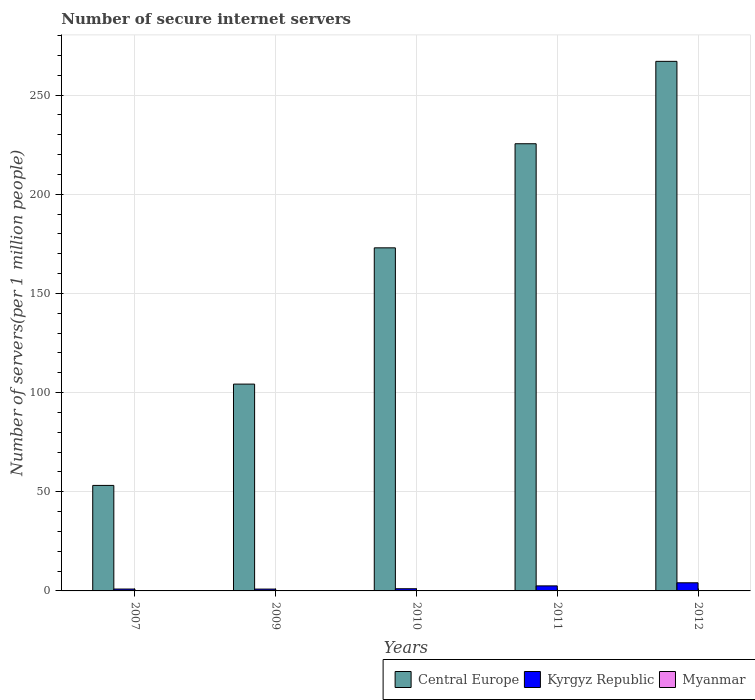Are the number of bars on each tick of the X-axis equal?
Provide a succinct answer. Yes. How many bars are there on the 4th tick from the left?
Offer a terse response. 3. What is the label of the 1st group of bars from the left?
Make the answer very short. 2007. What is the number of secure internet servers in Myanmar in 2009?
Ensure brevity in your answer.  0.02. Across all years, what is the maximum number of secure internet servers in Kyrgyz Republic?
Offer a terse response. 4.1. Across all years, what is the minimum number of secure internet servers in Myanmar?
Your response must be concise. 0.02. In which year was the number of secure internet servers in Kyrgyz Republic maximum?
Give a very brief answer. 2012. In which year was the number of secure internet servers in Myanmar minimum?
Offer a very short reply. 2009. What is the total number of secure internet servers in Kyrgyz Republic in the graph?
Your answer should be very brief. 9.62. What is the difference between the number of secure internet servers in Myanmar in 2007 and that in 2009?
Keep it short and to the point. 0. What is the difference between the number of secure internet servers in Kyrgyz Republic in 2011 and the number of secure internet servers in Central Europe in 2012?
Your answer should be compact. -264.44. What is the average number of secure internet servers in Myanmar per year?
Your answer should be very brief. 0.05. In the year 2010, what is the difference between the number of secure internet servers in Central Europe and number of secure internet servers in Myanmar?
Provide a short and direct response. 172.91. What is the ratio of the number of secure internet servers in Kyrgyz Republic in 2007 to that in 2010?
Give a very brief answer. 0.86. Is the difference between the number of secure internet servers in Central Europe in 2007 and 2010 greater than the difference between the number of secure internet servers in Myanmar in 2007 and 2010?
Your response must be concise. No. What is the difference between the highest and the second highest number of secure internet servers in Kyrgyz Republic?
Provide a succinct answer. 1.56. What is the difference between the highest and the lowest number of secure internet servers in Myanmar?
Offer a terse response. 0.08. Is the sum of the number of secure internet servers in Central Europe in 2010 and 2011 greater than the maximum number of secure internet servers in Myanmar across all years?
Provide a succinct answer. Yes. What does the 1st bar from the left in 2009 represents?
Your answer should be very brief. Central Europe. What does the 3rd bar from the right in 2007 represents?
Offer a very short reply. Central Europe. How many bars are there?
Keep it short and to the point. 15. Are the values on the major ticks of Y-axis written in scientific E-notation?
Offer a very short reply. No. Does the graph contain grids?
Offer a very short reply. Yes. Where does the legend appear in the graph?
Give a very brief answer. Bottom right. How are the legend labels stacked?
Provide a short and direct response. Horizontal. What is the title of the graph?
Your answer should be compact. Number of secure internet servers. Does "High income" appear as one of the legend labels in the graph?
Provide a succinct answer. No. What is the label or title of the Y-axis?
Keep it short and to the point. Number of servers(per 1 million people). What is the Number of servers(per 1 million people) of Central Europe in 2007?
Give a very brief answer. 53.19. What is the Number of servers(per 1 million people) of Kyrgyz Republic in 2007?
Offer a very short reply. 0.95. What is the Number of servers(per 1 million people) in Myanmar in 2007?
Give a very brief answer. 0.02. What is the Number of servers(per 1 million people) in Central Europe in 2009?
Provide a succinct answer. 104.27. What is the Number of servers(per 1 million people) in Kyrgyz Republic in 2009?
Ensure brevity in your answer.  0.93. What is the Number of servers(per 1 million people) of Myanmar in 2009?
Keep it short and to the point. 0.02. What is the Number of servers(per 1 million people) in Central Europe in 2010?
Give a very brief answer. 172.97. What is the Number of servers(per 1 million people) in Kyrgyz Republic in 2010?
Give a very brief answer. 1.1. What is the Number of servers(per 1 million people) of Myanmar in 2010?
Keep it short and to the point. 0.06. What is the Number of servers(per 1 million people) of Central Europe in 2011?
Provide a short and direct response. 225.45. What is the Number of servers(per 1 million people) in Kyrgyz Republic in 2011?
Ensure brevity in your answer.  2.54. What is the Number of servers(per 1 million people) of Myanmar in 2011?
Provide a succinct answer. 0.08. What is the Number of servers(per 1 million people) of Central Europe in 2012?
Provide a short and direct response. 266.98. What is the Number of servers(per 1 million people) in Kyrgyz Republic in 2012?
Offer a terse response. 4.1. What is the Number of servers(per 1 million people) of Myanmar in 2012?
Ensure brevity in your answer.  0.1. Across all years, what is the maximum Number of servers(per 1 million people) in Central Europe?
Offer a very short reply. 266.98. Across all years, what is the maximum Number of servers(per 1 million people) of Kyrgyz Republic?
Ensure brevity in your answer.  4.1. Across all years, what is the maximum Number of servers(per 1 million people) of Myanmar?
Offer a very short reply. 0.1. Across all years, what is the minimum Number of servers(per 1 million people) in Central Europe?
Offer a terse response. 53.19. Across all years, what is the minimum Number of servers(per 1 million people) in Kyrgyz Republic?
Keep it short and to the point. 0.93. Across all years, what is the minimum Number of servers(per 1 million people) of Myanmar?
Offer a terse response. 0.02. What is the total Number of servers(per 1 million people) of Central Europe in the graph?
Offer a very short reply. 822.86. What is the total Number of servers(per 1 million people) in Kyrgyz Republic in the graph?
Your response must be concise. 9.62. What is the total Number of servers(per 1 million people) in Myanmar in the graph?
Your response must be concise. 0.27. What is the difference between the Number of servers(per 1 million people) of Central Europe in 2007 and that in 2009?
Your answer should be very brief. -51.07. What is the difference between the Number of servers(per 1 million people) of Kyrgyz Republic in 2007 and that in 2009?
Provide a succinct answer. 0.02. What is the difference between the Number of servers(per 1 million people) in Myanmar in 2007 and that in 2009?
Make the answer very short. 0. What is the difference between the Number of servers(per 1 million people) in Central Europe in 2007 and that in 2010?
Your response must be concise. -119.78. What is the difference between the Number of servers(per 1 million people) in Kyrgyz Republic in 2007 and that in 2010?
Provide a short and direct response. -0.15. What is the difference between the Number of servers(per 1 million people) in Myanmar in 2007 and that in 2010?
Ensure brevity in your answer.  -0.04. What is the difference between the Number of servers(per 1 million people) in Central Europe in 2007 and that in 2011?
Your response must be concise. -172.26. What is the difference between the Number of servers(per 1 million people) in Kyrgyz Republic in 2007 and that in 2011?
Provide a succinct answer. -1.59. What is the difference between the Number of servers(per 1 million people) in Myanmar in 2007 and that in 2011?
Keep it short and to the point. -0.06. What is the difference between the Number of servers(per 1 million people) of Central Europe in 2007 and that in 2012?
Your answer should be very brief. -213.79. What is the difference between the Number of servers(per 1 million people) in Kyrgyz Republic in 2007 and that in 2012?
Your response must be concise. -3.15. What is the difference between the Number of servers(per 1 million people) in Myanmar in 2007 and that in 2012?
Provide a succinct answer. -0.08. What is the difference between the Number of servers(per 1 million people) in Central Europe in 2009 and that in 2010?
Make the answer very short. -68.7. What is the difference between the Number of servers(per 1 million people) in Kyrgyz Republic in 2009 and that in 2010?
Ensure brevity in your answer.  -0.17. What is the difference between the Number of servers(per 1 million people) in Myanmar in 2009 and that in 2010?
Your answer should be compact. -0.04. What is the difference between the Number of servers(per 1 million people) in Central Europe in 2009 and that in 2011?
Offer a very short reply. -121.18. What is the difference between the Number of servers(per 1 million people) of Kyrgyz Republic in 2009 and that in 2011?
Provide a succinct answer. -1.61. What is the difference between the Number of servers(per 1 million people) of Myanmar in 2009 and that in 2011?
Keep it short and to the point. -0.06. What is the difference between the Number of servers(per 1 million people) in Central Europe in 2009 and that in 2012?
Ensure brevity in your answer.  -162.72. What is the difference between the Number of servers(per 1 million people) of Kyrgyz Republic in 2009 and that in 2012?
Your answer should be very brief. -3.17. What is the difference between the Number of servers(per 1 million people) of Myanmar in 2009 and that in 2012?
Offer a very short reply. -0.08. What is the difference between the Number of servers(per 1 million people) of Central Europe in 2010 and that in 2011?
Provide a short and direct response. -52.48. What is the difference between the Number of servers(per 1 million people) of Kyrgyz Republic in 2010 and that in 2011?
Offer a terse response. -1.44. What is the difference between the Number of servers(per 1 million people) of Myanmar in 2010 and that in 2011?
Make the answer very short. -0.02. What is the difference between the Number of servers(per 1 million people) in Central Europe in 2010 and that in 2012?
Ensure brevity in your answer.  -94.01. What is the difference between the Number of servers(per 1 million people) in Kyrgyz Republic in 2010 and that in 2012?
Offer a terse response. -3. What is the difference between the Number of servers(per 1 million people) of Myanmar in 2010 and that in 2012?
Your answer should be very brief. -0.04. What is the difference between the Number of servers(per 1 million people) of Central Europe in 2011 and that in 2012?
Provide a short and direct response. -41.53. What is the difference between the Number of servers(per 1 million people) in Kyrgyz Republic in 2011 and that in 2012?
Give a very brief answer. -1.56. What is the difference between the Number of servers(per 1 million people) in Myanmar in 2011 and that in 2012?
Provide a short and direct response. -0.02. What is the difference between the Number of servers(per 1 million people) of Central Europe in 2007 and the Number of servers(per 1 million people) of Kyrgyz Republic in 2009?
Provide a succinct answer. 52.26. What is the difference between the Number of servers(per 1 million people) in Central Europe in 2007 and the Number of servers(per 1 million people) in Myanmar in 2009?
Your response must be concise. 53.17. What is the difference between the Number of servers(per 1 million people) of Kyrgyz Republic in 2007 and the Number of servers(per 1 million people) of Myanmar in 2009?
Your answer should be compact. 0.93. What is the difference between the Number of servers(per 1 million people) in Central Europe in 2007 and the Number of servers(per 1 million people) in Kyrgyz Republic in 2010?
Provide a succinct answer. 52.09. What is the difference between the Number of servers(per 1 million people) in Central Europe in 2007 and the Number of servers(per 1 million people) in Myanmar in 2010?
Your answer should be very brief. 53.13. What is the difference between the Number of servers(per 1 million people) in Kyrgyz Republic in 2007 and the Number of servers(per 1 million people) in Myanmar in 2010?
Keep it short and to the point. 0.89. What is the difference between the Number of servers(per 1 million people) of Central Europe in 2007 and the Number of servers(per 1 million people) of Kyrgyz Republic in 2011?
Your answer should be compact. 50.65. What is the difference between the Number of servers(per 1 million people) in Central Europe in 2007 and the Number of servers(per 1 million people) in Myanmar in 2011?
Ensure brevity in your answer.  53.12. What is the difference between the Number of servers(per 1 million people) in Kyrgyz Republic in 2007 and the Number of servers(per 1 million people) in Myanmar in 2011?
Provide a short and direct response. 0.87. What is the difference between the Number of servers(per 1 million people) in Central Europe in 2007 and the Number of servers(per 1 million people) in Kyrgyz Republic in 2012?
Provide a succinct answer. 49.09. What is the difference between the Number of servers(per 1 million people) of Central Europe in 2007 and the Number of servers(per 1 million people) of Myanmar in 2012?
Provide a succinct answer. 53.1. What is the difference between the Number of servers(per 1 million people) of Kyrgyz Republic in 2007 and the Number of servers(per 1 million people) of Myanmar in 2012?
Keep it short and to the point. 0.85. What is the difference between the Number of servers(per 1 million people) of Central Europe in 2009 and the Number of servers(per 1 million people) of Kyrgyz Republic in 2010?
Your answer should be very brief. 103.16. What is the difference between the Number of servers(per 1 million people) in Central Europe in 2009 and the Number of servers(per 1 million people) in Myanmar in 2010?
Make the answer very short. 104.21. What is the difference between the Number of servers(per 1 million people) of Kyrgyz Republic in 2009 and the Number of servers(per 1 million people) of Myanmar in 2010?
Ensure brevity in your answer.  0.87. What is the difference between the Number of servers(per 1 million people) in Central Europe in 2009 and the Number of servers(per 1 million people) in Kyrgyz Republic in 2011?
Keep it short and to the point. 101.73. What is the difference between the Number of servers(per 1 million people) in Central Europe in 2009 and the Number of servers(per 1 million people) in Myanmar in 2011?
Offer a terse response. 104.19. What is the difference between the Number of servers(per 1 million people) in Kyrgyz Republic in 2009 and the Number of servers(per 1 million people) in Myanmar in 2011?
Your response must be concise. 0.85. What is the difference between the Number of servers(per 1 million people) of Central Europe in 2009 and the Number of servers(per 1 million people) of Kyrgyz Republic in 2012?
Keep it short and to the point. 100.16. What is the difference between the Number of servers(per 1 million people) in Central Europe in 2009 and the Number of servers(per 1 million people) in Myanmar in 2012?
Ensure brevity in your answer.  104.17. What is the difference between the Number of servers(per 1 million people) of Kyrgyz Republic in 2009 and the Number of servers(per 1 million people) of Myanmar in 2012?
Offer a terse response. 0.83. What is the difference between the Number of servers(per 1 million people) of Central Europe in 2010 and the Number of servers(per 1 million people) of Kyrgyz Republic in 2011?
Give a very brief answer. 170.43. What is the difference between the Number of servers(per 1 million people) of Central Europe in 2010 and the Number of servers(per 1 million people) of Myanmar in 2011?
Make the answer very short. 172.89. What is the difference between the Number of servers(per 1 million people) in Kyrgyz Republic in 2010 and the Number of servers(per 1 million people) in Myanmar in 2011?
Ensure brevity in your answer.  1.02. What is the difference between the Number of servers(per 1 million people) in Central Europe in 2010 and the Number of servers(per 1 million people) in Kyrgyz Republic in 2012?
Provide a succinct answer. 168.87. What is the difference between the Number of servers(per 1 million people) of Central Europe in 2010 and the Number of servers(per 1 million people) of Myanmar in 2012?
Offer a very short reply. 172.88. What is the difference between the Number of servers(per 1 million people) of Kyrgyz Republic in 2010 and the Number of servers(per 1 million people) of Myanmar in 2012?
Make the answer very short. 1.01. What is the difference between the Number of servers(per 1 million people) of Central Europe in 2011 and the Number of servers(per 1 million people) of Kyrgyz Republic in 2012?
Your answer should be compact. 221.35. What is the difference between the Number of servers(per 1 million people) in Central Europe in 2011 and the Number of servers(per 1 million people) in Myanmar in 2012?
Give a very brief answer. 225.35. What is the difference between the Number of servers(per 1 million people) in Kyrgyz Republic in 2011 and the Number of servers(per 1 million people) in Myanmar in 2012?
Offer a terse response. 2.44. What is the average Number of servers(per 1 million people) of Central Europe per year?
Provide a succinct answer. 164.57. What is the average Number of servers(per 1 million people) of Kyrgyz Republic per year?
Ensure brevity in your answer.  1.92. What is the average Number of servers(per 1 million people) in Myanmar per year?
Offer a very short reply. 0.05. In the year 2007, what is the difference between the Number of servers(per 1 million people) in Central Europe and Number of servers(per 1 million people) in Kyrgyz Republic?
Your answer should be very brief. 52.24. In the year 2007, what is the difference between the Number of servers(per 1 million people) of Central Europe and Number of servers(per 1 million people) of Myanmar?
Your response must be concise. 53.17. In the year 2007, what is the difference between the Number of servers(per 1 million people) of Kyrgyz Republic and Number of servers(per 1 million people) of Myanmar?
Ensure brevity in your answer.  0.93. In the year 2009, what is the difference between the Number of servers(per 1 million people) in Central Europe and Number of servers(per 1 million people) in Kyrgyz Republic?
Provide a short and direct response. 103.34. In the year 2009, what is the difference between the Number of servers(per 1 million people) of Central Europe and Number of servers(per 1 million people) of Myanmar?
Offer a very short reply. 104.25. In the year 2009, what is the difference between the Number of servers(per 1 million people) of Kyrgyz Republic and Number of servers(per 1 million people) of Myanmar?
Your answer should be compact. 0.91. In the year 2010, what is the difference between the Number of servers(per 1 million people) of Central Europe and Number of servers(per 1 million people) of Kyrgyz Republic?
Provide a short and direct response. 171.87. In the year 2010, what is the difference between the Number of servers(per 1 million people) in Central Europe and Number of servers(per 1 million people) in Myanmar?
Your answer should be very brief. 172.91. In the year 2010, what is the difference between the Number of servers(per 1 million people) of Kyrgyz Republic and Number of servers(per 1 million people) of Myanmar?
Offer a very short reply. 1.04. In the year 2011, what is the difference between the Number of servers(per 1 million people) in Central Europe and Number of servers(per 1 million people) in Kyrgyz Republic?
Offer a terse response. 222.91. In the year 2011, what is the difference between the Number of servers(per 1 million people) in Central Europe and Number of servers(per 1 million people) in Myanmar?
Your answer should be very brief. 225.37. In the year 2011, what is the difference between the Number of servers(per 1 million people) of Kyrgyz Republic and Number of servers(per 1 million people) of Myanmar?
Your answer should be very brief. 2.46. In the year 2012, what is the difference between the Number of servers(per 1 million people) of Central Europe and Number of servers(per 1 million people) of Kyrgyz Republic?
Make the answer very short. 262.88. In the year 2012, what is the difference between the Number of servers(per 1 million people) in Central Europe and Number of servers(per 1 million people) in Myanmar?
Provide a short and direct response. 266.89. In the year 2012, what is the difference between the Number of servers(per 1 million people) in Kyrgyz Republic and Number of servers(per 1 million people) in Myanmar?
Offer a very short reply. 4.01. What is the ratio of the Number of servers(per 1 million people) in Central Europe in 2007 to that in 2009?
Make the answer very short. 0.51. What is the ratio of the Number of servers(per 1 million people) in Kyrgyz Republic in 2007 to that in 2009?
Your answer should be very brief. 1.02. What is the ratio of the Number of servers(per 1 million people) in Myanmar in 2007 to that in 2009?
Your answer should be very brief. 1.01. What is the ratio of the Number of servers(per 1 million people) of Central Europe in 2007 to that in 2010?
Your answer should be compact. 0.31. What is the ratio of the Number of servers(per 1 million people) in Kyrgyz Republic in 2007 to that in 2010?
Offer a very short reply. 0.86. What is the ratio of the Number of servers(per 1 million people) in Myanmar in 2007 to that in 2010?
Provide a succinct answer. 0.34. What is the ratio of the Number of servers(per 1 million people) of Central Europe in 2007 to that in 2011?
Offer a terse response. 0.24. What is the ratio of the Number of servers(per 1 million people) of Kyrgyz Republic in 2007 to that in 2011?
Provide a short and direct response. 0.37. What is the ratio of the Number of servers(per 1 million people) of Myanmar in 2007 to that in 2011?
Provide a short and direct response. 0.26. What is the ratio of the Number of servers(per 1 million people) in Central Europe in 2007 to that in 2012?
Give a very brief answer. 0.2. What is the ratio of the Number of servers(per 1 million people) of Kyrgyz Republic in 2007 to that in 2012?
Your answer should be very brief. 0.23. What is the ratio of the Number of servers(per 1 million people) in Myanmar in 2007 to that in 2012?
Make the answer very short. 0.21. What is the ratio of the Number of servers(per 1 million people) of Central Europe in 2009 to that in 2010?
Ensure brevity in your answer.  0.6. What is the ratio of the Number of servers(per 1 million people) of Kyrgyz Republic in 2009 to that in 2010?
Your response must be concise. 0.84. What is the ratio of the Number of servers(per 1 million people) in Myanmar in 2009 to that in 2010?
Make the answer very short. 0.34. What is the ratio of the Number of servers(per 1 million people) in Central Europe in 2009 to that in 2011?
Make the answer very short. 0.46. What is the ratio of the Number of servers(per 1 million people) of Kyrgyz Republic in 2009 to that in 2011?
Keep it short and to the point. 0.37. What is the ratio of the Number of servers(per 1 million people) in Myanmar in 2009 to that in 2011?
Your answer should be very brief. 0.25. What is the ratio of the Number of servers(per 1 million people) in Central Europe in 2009 to that in 2012?
Make the answer very short. 0.39. What is the ratio of the Number of servers(per 1 million people) of Kyrgyz Republic in 2009 to that in 2012?
Your response must be concise. 0.23. What is the ratio of the Number of servers(per 1 million people) of Myanmar in 2009 to that in 2012?
Give a very brief answer. 0.2. What is the ratio of the Number of servers(per 1 million people) in Central Europe in 2010 to that in 2011?
Keep it short and to the point. 0.77. What is the ratio of the Number of servers(per 1 million people) in Kyrgyz Republic in 2010 to that in 2011?
Your answer should be compact. 0.43. What is the ratio of the Number of servers(per 1 million people) of Myanmar in 2010 to that in 2011?
Your response must be concise. 0.76. What is the ratio of the Number of servers(per 1 million people) in Central Europe in 2010 to that in 2012?
Keep it short and to the point. 0.65. What is the ratio of the Number of servers(per 1 million people) of Kyrgyz Republic in 2010 to that in 2012?
Offer a very short reply. 0.27. What is the ratio of the Number of servers(per 1 million people) of Myanmar in 2010 to that in 2012?
Offer a terse response. 0.61. What is the ratio of the Number of servers(per 1 million people) in Central Europe in 2011 to that in 2012?
Your answer should be very brief. 0.84. What is the ratio of the Number of servers(per 1 million people) of Kyrgyz Republic in 2011 to that in 2012?
Give a very brief answer. 0.62. What is the ratio of the Number of servers(per 1 million people) in Myanmar in 2011 to that in 2012?
Offer a terse response. 0.81. What is the difference between the highest and the second highest Number of servers(per 1 million people) of Central Europe?
Your answer should be compact. 41.53. What is the difference between the highest and the second highest Number of servers(per 1 million people) in Kyrgyz Republic?
Your response must be concise. 1.56. What is the difference between the highest and the second highest Number of servers(per 1 million people) of Myanmar?
Provide a succinct answer. 0.02. What is the difference between the highest and the lowest Number of servers(per 1 million people) in Central Europe?
Give a very brief answer. 213.79. What is the difference between the highest and the lowest Number of servers(per 1 million people) in Kyrgyz Republic?
Give a very brief answer. 3.17. What is the difference between the highest and the lowest Number of servers(per 1 million people) in Myanmar?
Offer a very short reply. 0.08. 